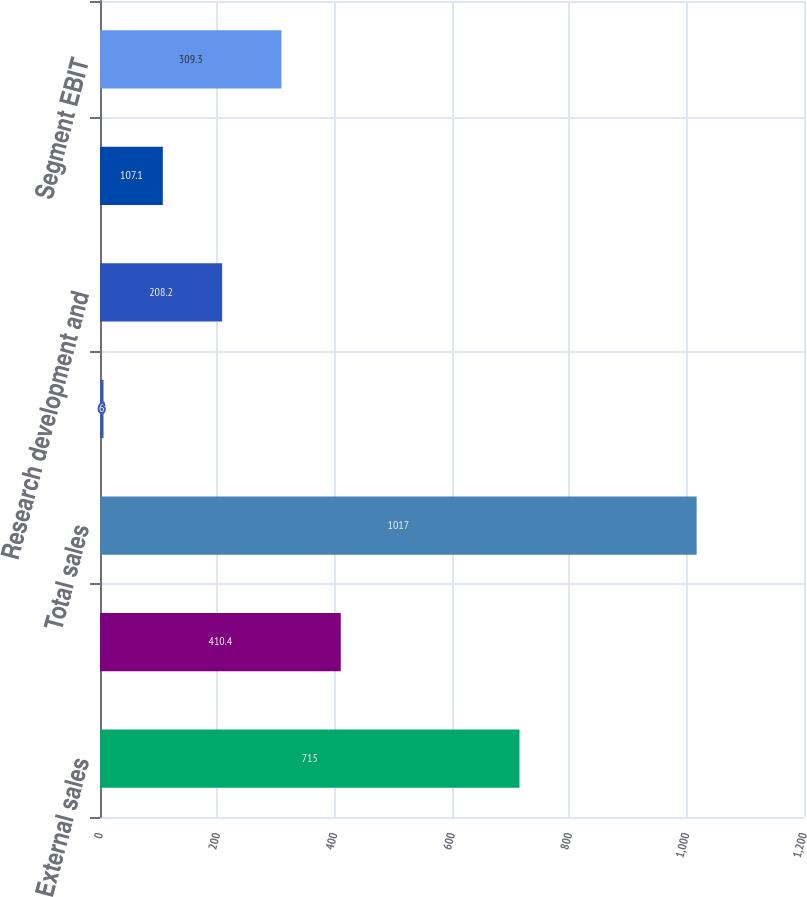Convert chart. <chart><loc_0><loc_0><loc_500><loc_500><bar_chart><fcel>External sales<fcel>Intersegment sales<fcel>Total sales<fcel>Depreciation and amortization<fcel>Research development and<fcel>Equity royalty and interest<fcel>Segment EBIT<nl><fcel>715<fcel>410.4<fcel>1017<fcel>6<fcel>208.2<fcel>107.1<fcel>309.3<nl></chart> 